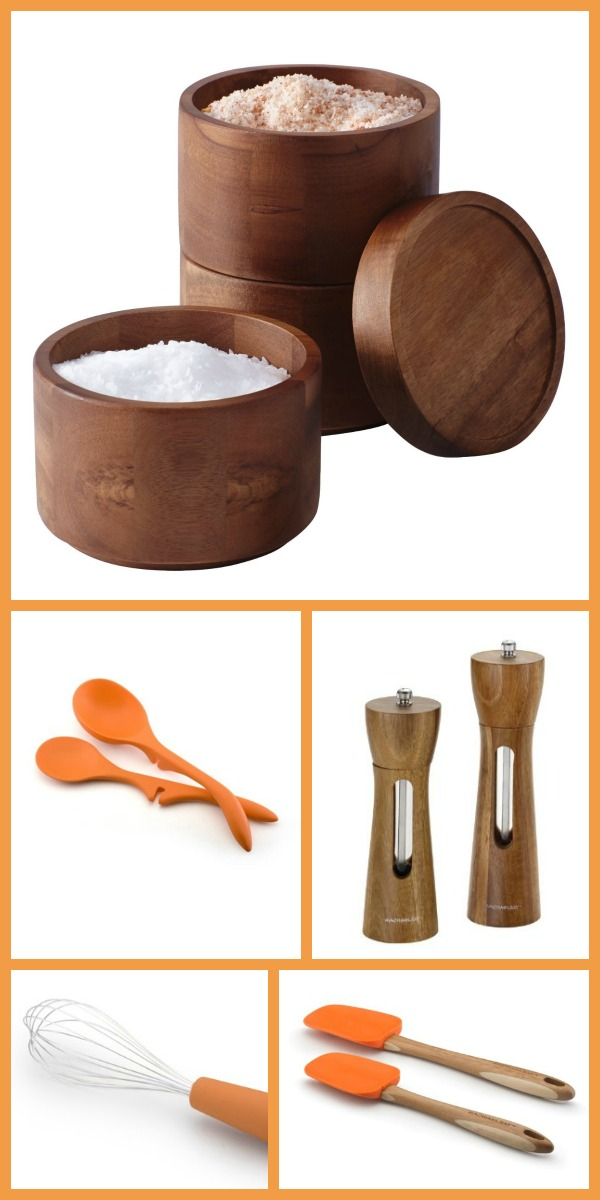Which item in the image would be the most reliable companion for a camping trip and why? The silicone spatulas would be the most reliable companion for a camping trip. Their heat resistance, lightweight, and versatility make them perfect for outdoor cooking. They can withstand high temperatures, making them ideal for use over open flames or portable stoves, and their flexible yet sturdy design allows for various cooking tasks, from stirring to scooping. 